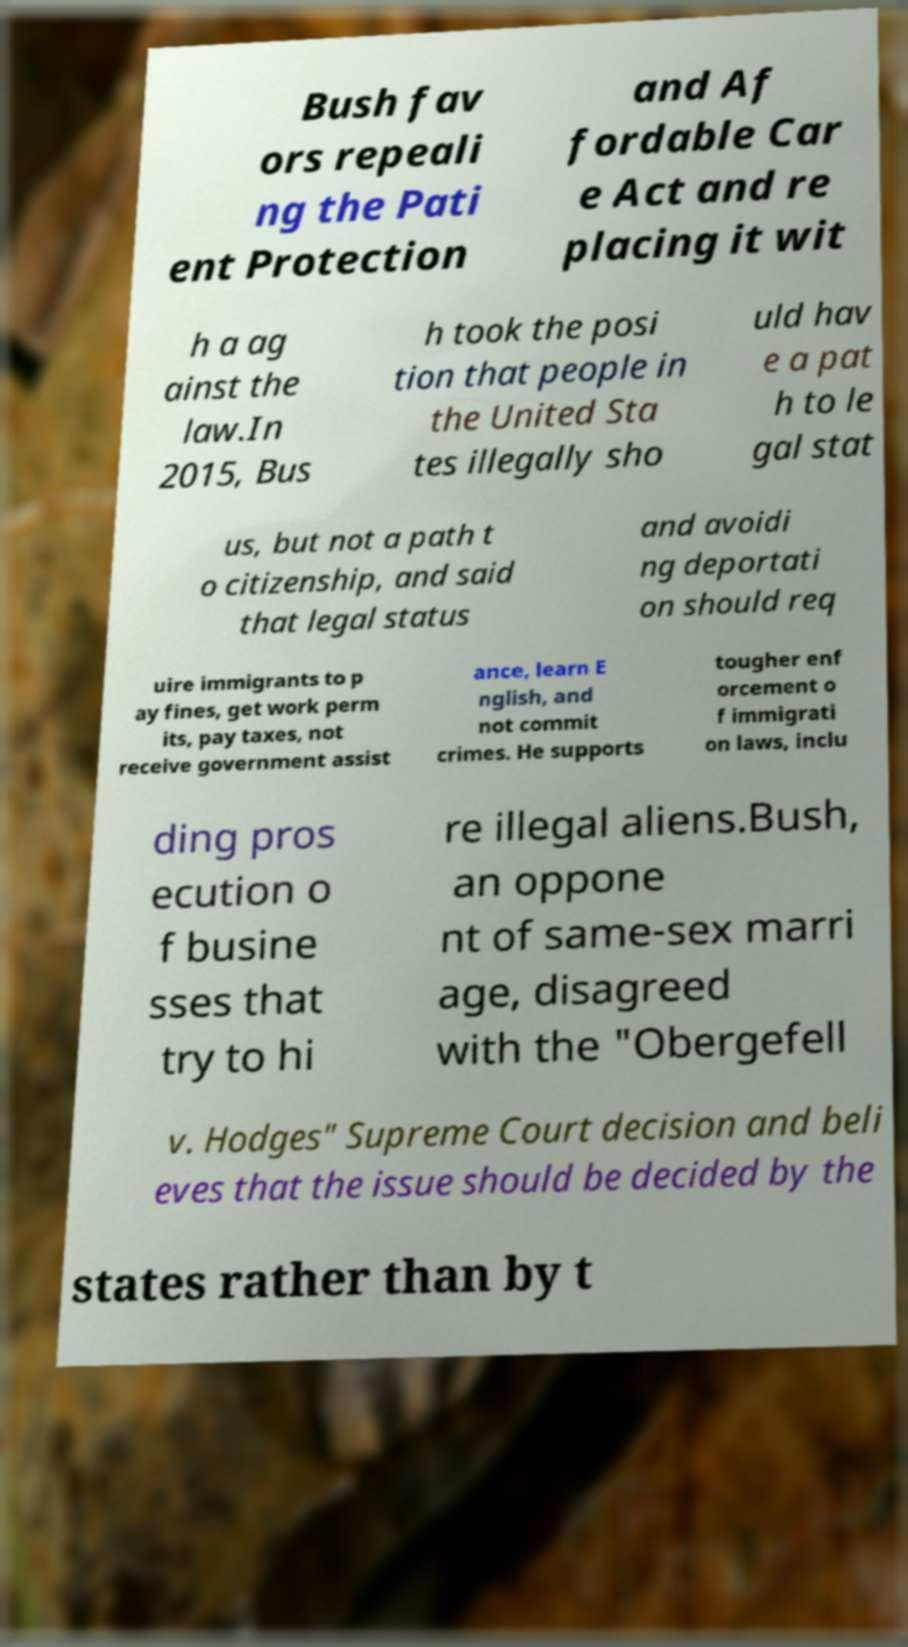For documentation purposes, I need the text within this image transcribed. Could you provide that? Bush fav ors repeali ng the Pati ent Protection and Af fordable Car e Act and re placing it wit h a ag ainst the law.In 2015, Bus h took the posi tion that people in the United Sta tes illegally sho uld hav e a pat h to le gal stat us, but not a path t o citizenship, and said that legal status and avoidi ng deportati on should req uire immigrants to p ay fines, get work perm its, pay taxes, not receive government assist ance, learn E nglish, and not commit crimes. He supports tougher enf orcement o f immigrati on laws, inclu ding pros ecution o f busine sses that try to hi re illegal aliens.Bush, an oppone nt of same-sex marri age, disagreed with the "Obergefell v. Hodges" Supreme Court decision and beli eves that the issue should be decided by the states rather than by t 